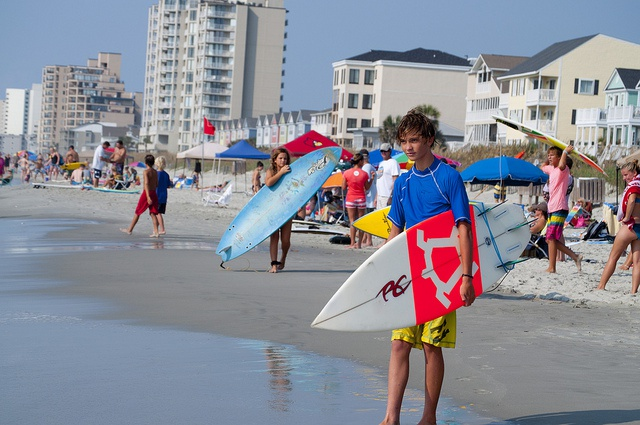Describe the objects in this image and their specific colors. I can see surfboard in darkgray, red, and lightgray tones, people in darkgray, maroon, black, and blue tones, surfboard in darkgray and lightblue tones, people in darkgray, brown, maroon, salmon, and black tones, and people in darkgray, brown, maroon, lightpink, and black tones in this image. 